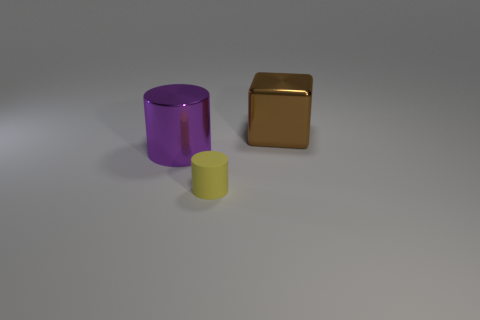Subtract all cylinders. How many objects are left? 1 Add 1 large cyan matte cubes. How many objects exist? 4 Subtract 0 blue cubes. How many objects are left? 3 Subtract all yellow rubber things. Subtract all tiny cylinders. How many objects are left? 1 Add 2 metal cubes. How many metal cubes are left? 3 Add 2 tiny purple things. How many tiny purple things exist? 2 